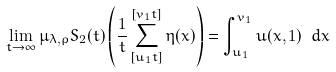Convert formula to latex. <formula><loc_0><loc_0><loc_500><loc_500>\lim _ { t \to \infty } \mu _ { \lambda , \rho } S _ { 2 } ( t ) \left ( \frac { 1 } { t } \sum _ { [ u _ { 1 } t ] } ^ { [ v _ { 1 } t ] } \eta ( x ) \right ) = \int _ { u _ { 1 } } ^ { v _ { 1 } } u ( x , 1 ) \ d x</formula> 